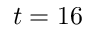Convert formula to latex. <formula><loc_0><loc_0><loc_500><loc_500>t = 1 6</formula> 